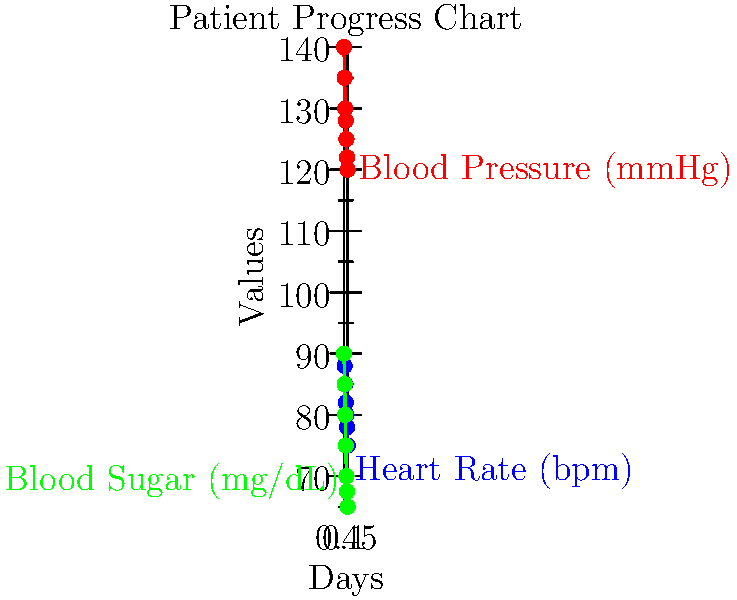Based on the patient progress chart, which health indicator shows the most significant improvement over the 7-day period, and what is the percentage decrease from Day 1 to Day 7 for this indicator? To determine which health indicator shows the most significant improvement and calculate its percentage decrease:

1. Calculate the percentage decrease for each indicator:

   Blood Pressure:
   Initial (Day 1): 140 mmHg
   Final (Day 7): 120 mmHg
   Percentage decrease = $\frac{140 - 120}{140} \times 100\% = 14.29\%$

   Heart Rate:
   Initial (Day 1): 90 bpm
   Final (Day 7): 75 bpm
   Percentage decrease = $\frac{90 - 75}{90} \times 100\% = 16.67\%$

   Blood Sugar:
   Initial (Day 1): 180 mg/dL
   Final (Day 7): 130 mg/dL
   Percentage decrease = $\frac{180 - 130}{180} \times 100\% = 27.78\%$

2. Compare the percentage decreases:
   Blood Pressure: 14.29%
   Heart Rate: 16.67%
   Blood Sugar: 27.78%

3. The health indicator with the highest percentage decrease shows the most significant improvement.

Therefore, Blood Sugar shows the most significant improvement with a 27.78% decrease over the 7-day period.
Answer: Blood Sugar, 27.78% 